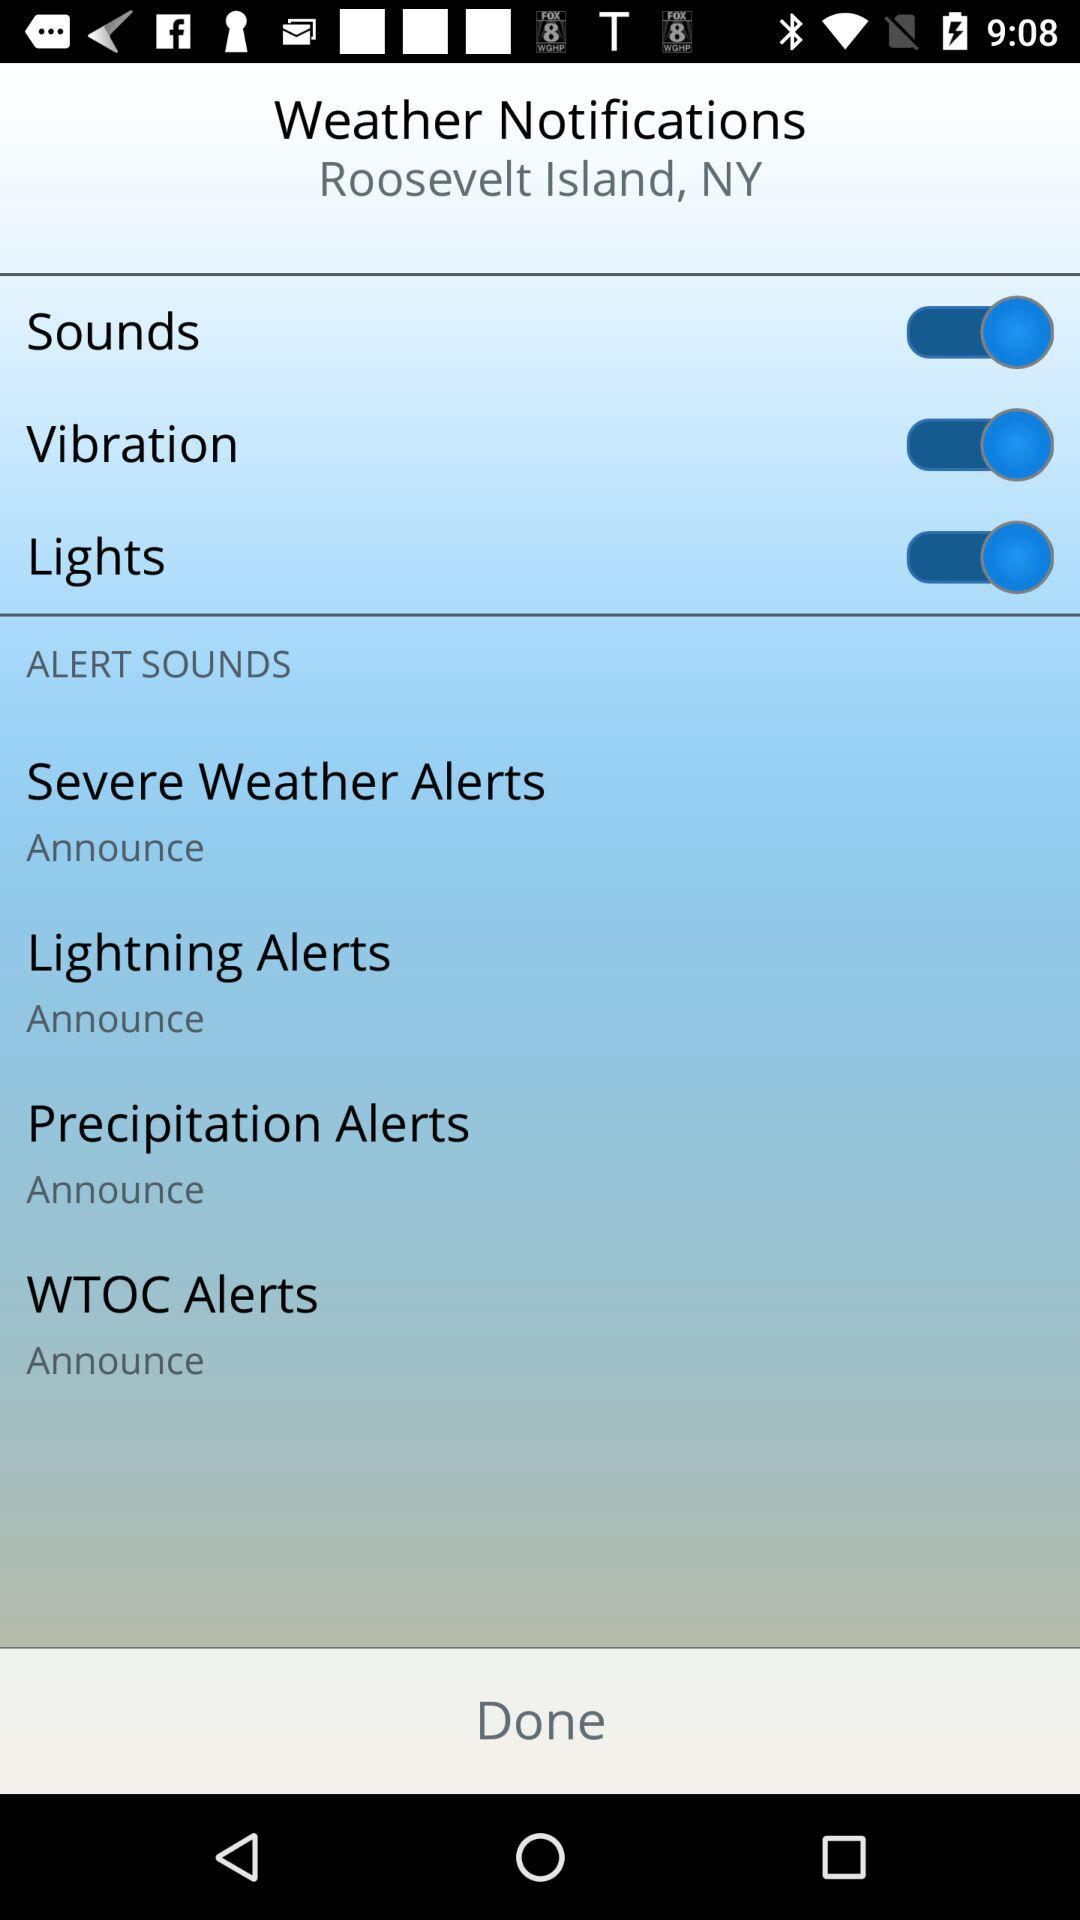What is the status of "Lights"? The status is "on". 